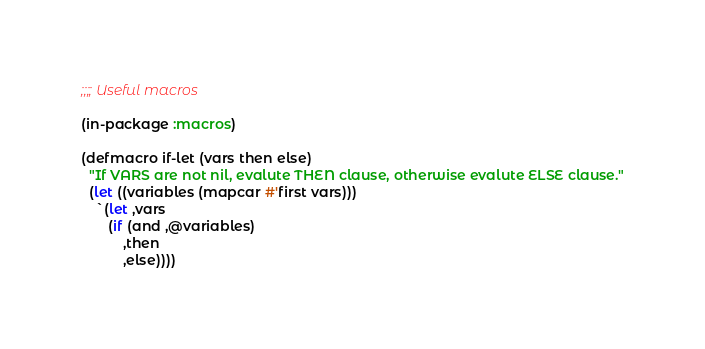<code> <loc_0><loc_0><loc_500><loc_500><_Lisp_>;;;; Useful macros

(in-package :macros)

(defmacro if-let (vars then else)
  "If VARS are not nil, evalute THEN clause, otherwise evalute ELSE clause."
  (let ((variables (mapcar #'first vars)))
    `(let ,vars
       (if (and ,@variables)
           ,then
           ,else))))
</code> 